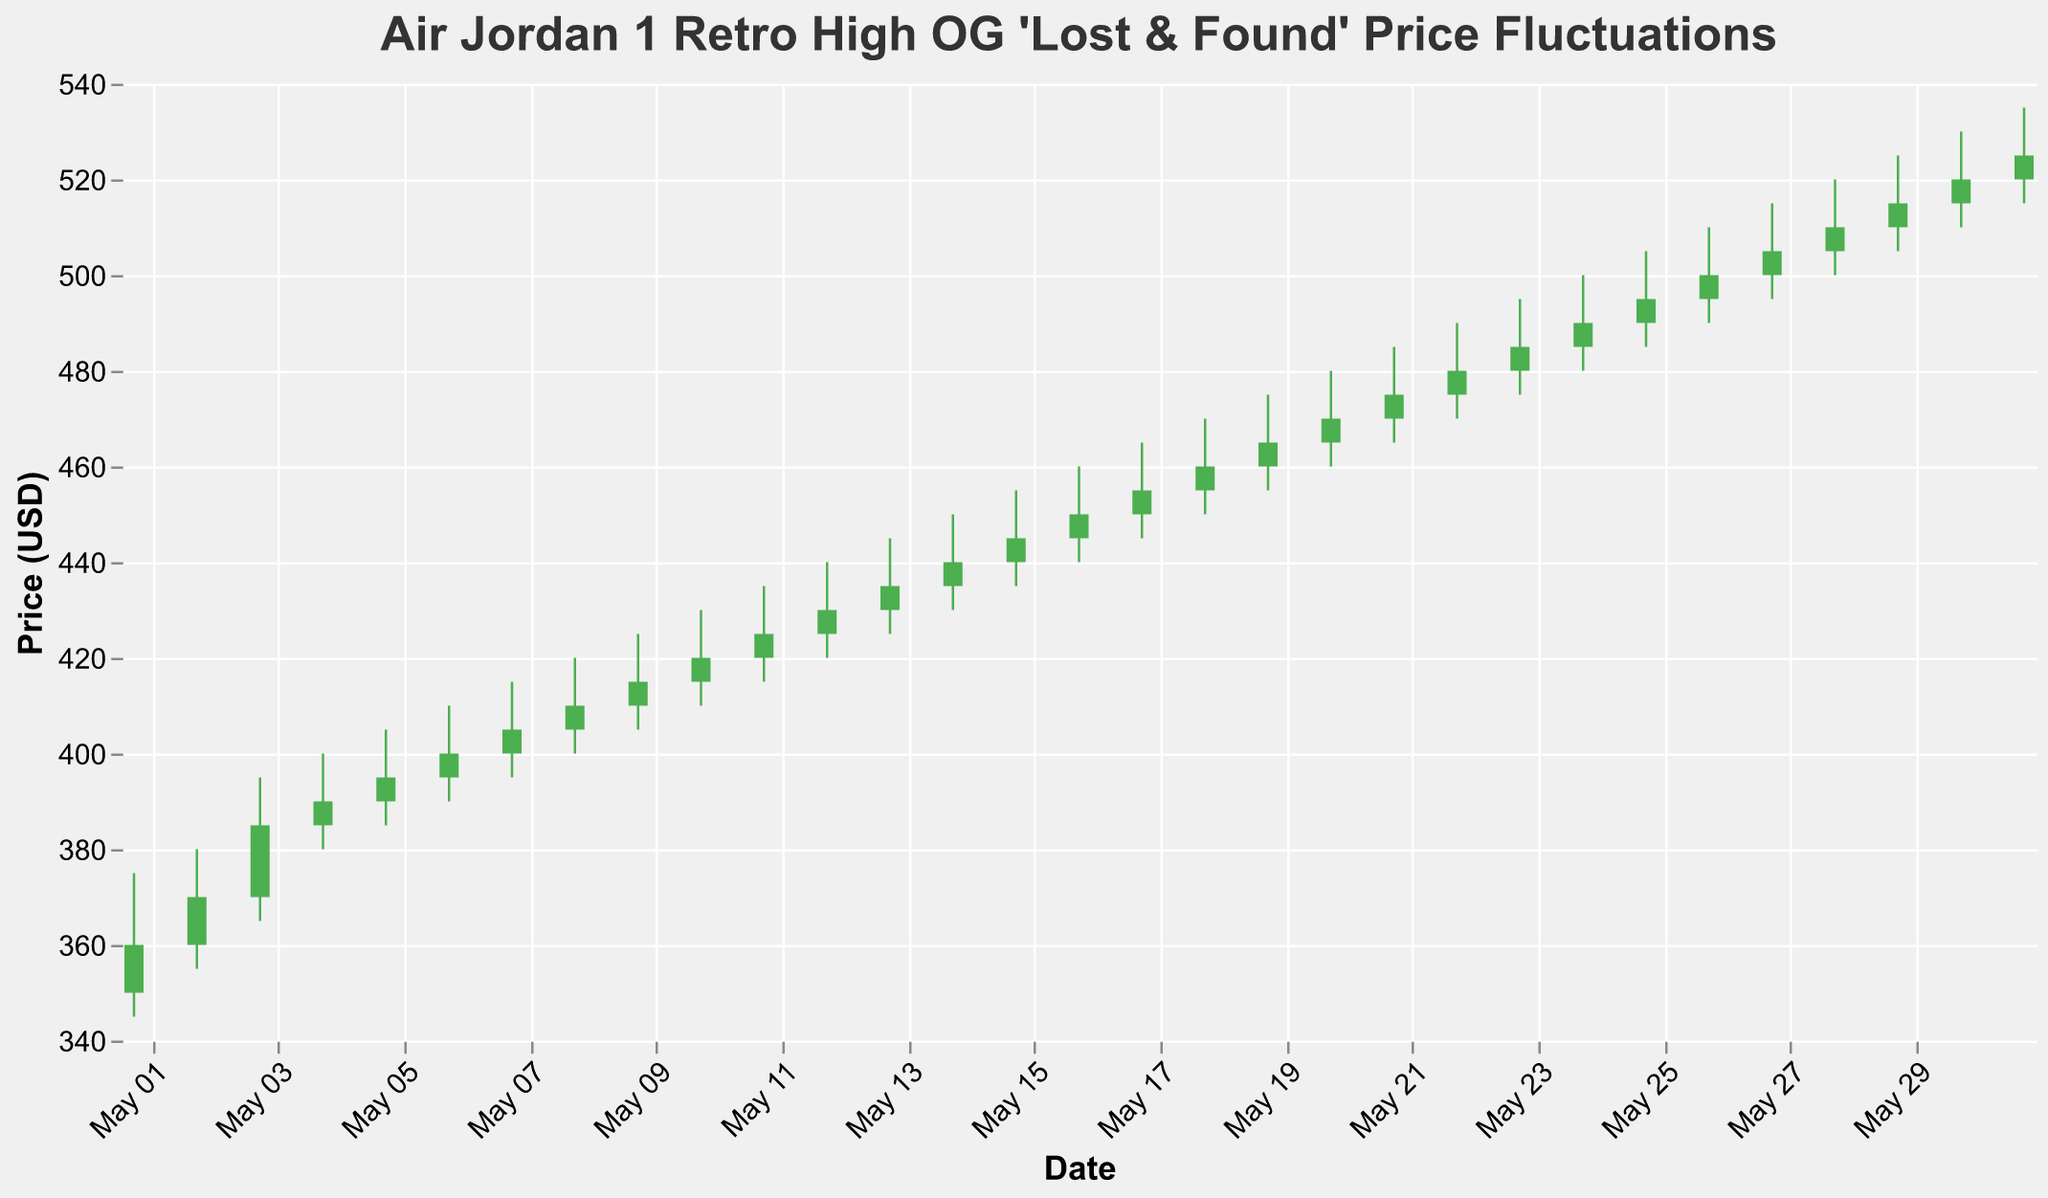What is the title of the chart? The title of the chart is displayed at the top and reads "Air Jordan 1 Retro High OG 'Lost & Found' Price Fluctuations"
Answer: Air Jordan 1 Retro High OG 'Lost & Found' Price Fluctuations How many data points are represented in the chart? The chart shows daily price fluctuations for the entire month of May, which means there are 31 data points, one for each day
Answer: 31 What was the highest price recorded in May for the Air Jordan 1 'Lost & Found' sneakers? The highest price recorded in May is shown as the High point in the OHLC chart, and the maximum value is 535 on May 31
Answer: 535 On which date did the sneakers open at 450 USD? Looking at the opening prices for each date, the sneakers opened at 450 USD on May 17
Answer: May 17 What was the closing price of the sneakers on May 15? The closing price is indicated on the chart for each day. On May 15, the closing price was 445 USD
Answer: 445 Which date saw the largest daily price range, and what was the range? The largest daily price range can be found by taking the highest high and subtracting the lowest low for each day. On May 31, the range is 535 - 515 = 20 USD
Answer: May 31, 20 USD How does the closing price on May 1 compare to the opening price on May 2? The closing price on May 1 was 360 USD, and the opening price on May 2 was also 360 USD, so they are equal
Answer: Equal What was the average opening price of the sneakers during the first week of May? The first week comprises May 1 to May 7; sum the opening prices (350, 360, 370, 385, 390, 395, 400) and then divide by 7. (350 + 360 + 370 + 385 + 390 + 395 + 400) / 7 = 378.57
Answer: 378.57 During which date did the sneakers see a price increase, and what was the magnitude of the increase? For a price increase, the close must be higher than the open. On May 2, the close (370) was higher than the open (360), with an increase of 10 USD. The magnitude of increase is 370 - 360 = 10
Answer: May 2, 10 USD Which date had the smallest difference between the high and the low prices, and what was this difference? The smallest difference can be determined by inspecting the range (High - Low) for each day. On May 8, the difference was 420 - 400 = 20 USD, which is the smallest difference
Answer: May 8, 20 USD 